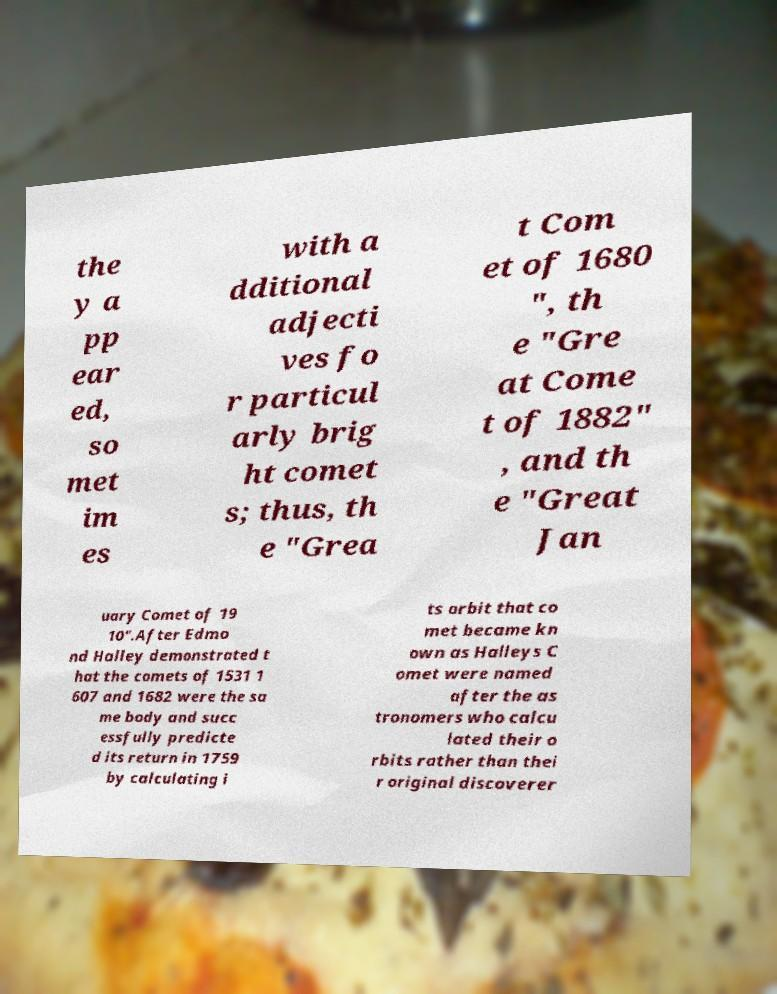Can you accurately transcribe the text from the provided image for me? the y a pp ear ed, so met im es with a dditional adjecti ves fo r particul arly brig ht comet s; thus, th e "Grea t Com et of 1680 ", th e "Gre at Come t of 1882" , and th e "Great Jan uary Comet of 19 10".After Edmo nd Halley demonstrated t hat the comets of 1531 1 607 and 1682 were the sa me body and succ essfully predicte d its return in 1759 by calculating i ts orbit that co met became kn own as Halleys C omet were named after the as tronomers who calcu lated their o rbits rather than thei r original discoverer 